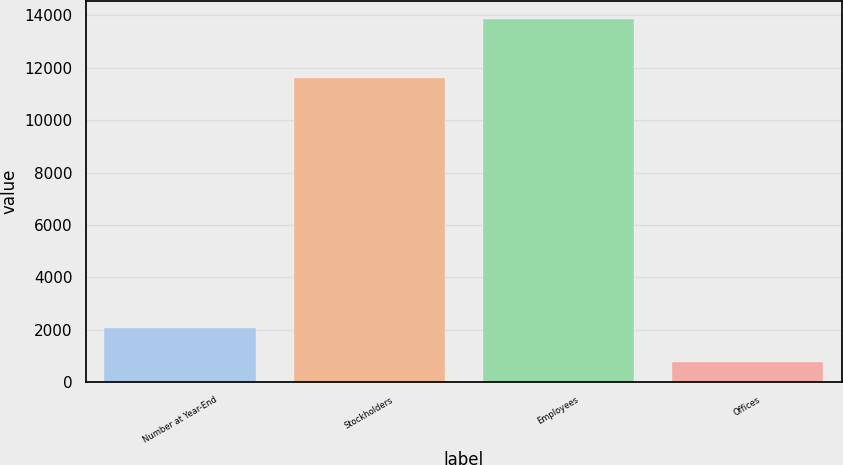Convert chart to OTSL. <chart><loc_0><loc_0><loc_500><loc_500><bar_chart><fcel>Number at Year-End<fcel>Stockholders<fcel>Employees<fcel>Offices<nl><fcel>2070.9<fcel>11611<fcel>13869<fcel>760<nl></chart> 